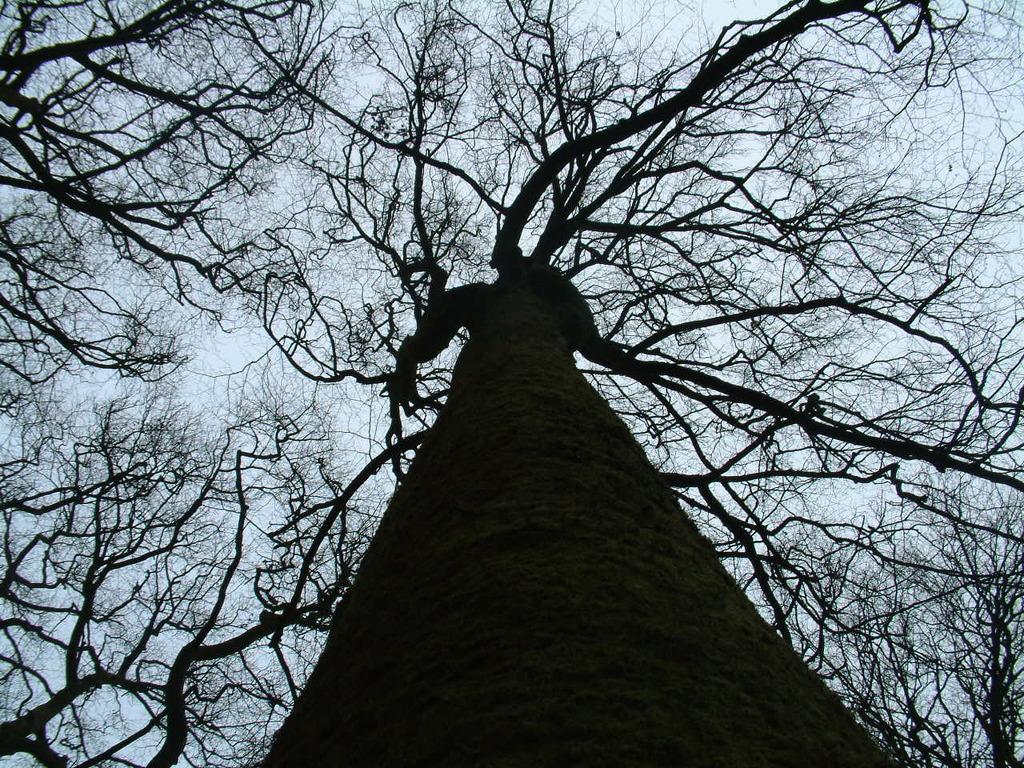Could you give a brief overview of what you see in this image? In this picture I can see trees and a cloudy sky. 